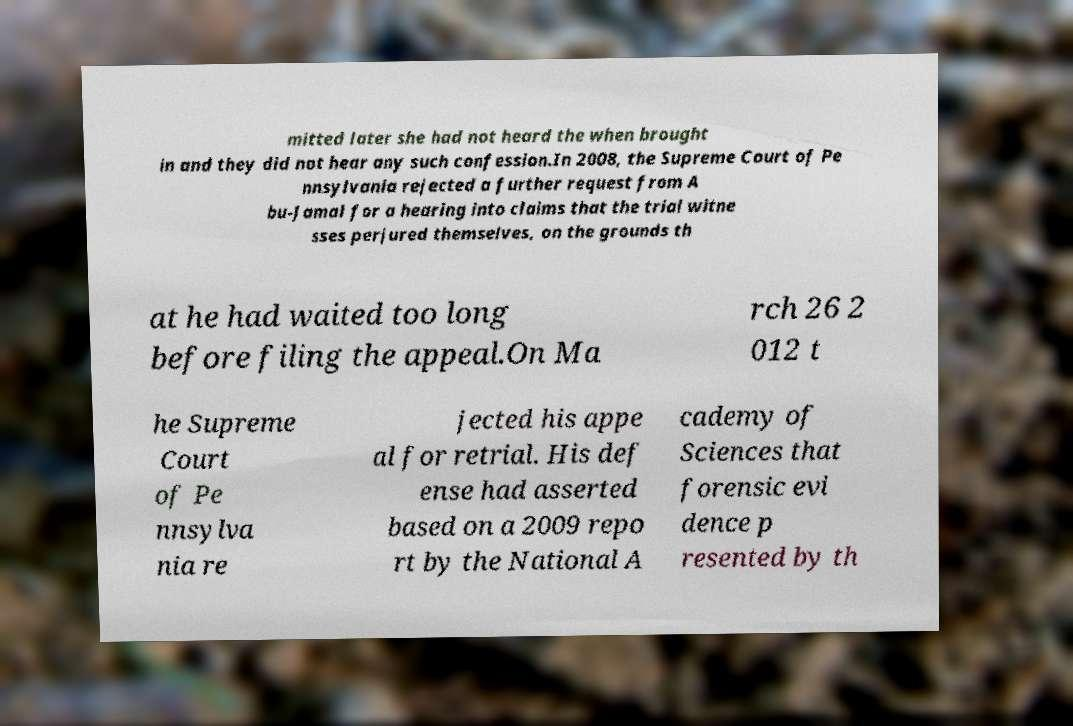I need the written content from this picture converted into text. Can you do that? mitted later she had not heard the when brought in and they did not hear any such confession.In 2008, the Supreme Court of Pe nnsylvania rejected a further request from A bu-Jamal for a hearing into claims that the trial witne sses perjured themselves, on the grounds th at he had waited too long before filing the appeal.On Ma rch 26 2 012 t he Supreme Court of Pe nnsylva nia re jected his appe al for retrial. His def ense had asserted based on a 2009 repo rt by the National A cademy of Sciences that forensic evi dence p resented by th 